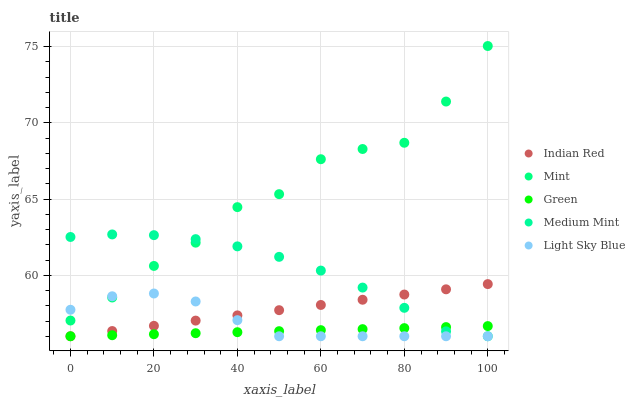Does Green have the minimum area under the curve?
Answer yes or no. Yes. Does Mint have the maximum area under the curve?
Answer yes or no. Yes. Does Light Sky Blue have the minimum area under the curve?
Answer yes or no. No. Does Light Sky Blue have the maximum area under the curve?
Answer yes or no. No. Is Indian Red the smoothest?
Answer yes or no. Yes. Is Mint the roughest?
Answer yes or no. Yes. Is Green the smoothest?
Answer yes or no. No. Is Green the roughest?
Answer yes or no. No. Does Medium Mint have the lowest value?
Answer yes or no. Yes. Does Mint have the lowest value?
Answer yes or no. No. Does Mint have the highest value?
Answer yes or no. Yes. Does Light Sky Blue have the highest value?
Answer yes or no. No. Is Indian Red less than Mint?
Answer yes or no. Yes. Is Mint greater than Green?
Answer yes or no. Yes. Does Indian Red intersect Green?
Answer yes or no. Yes. Is Indian Red less than Green?
Answer yes or no. No. Is Indian Red greater than Green?
Answer yes or no. No. Does Indian Red intersect Mint?
Answer yes or no. No. 